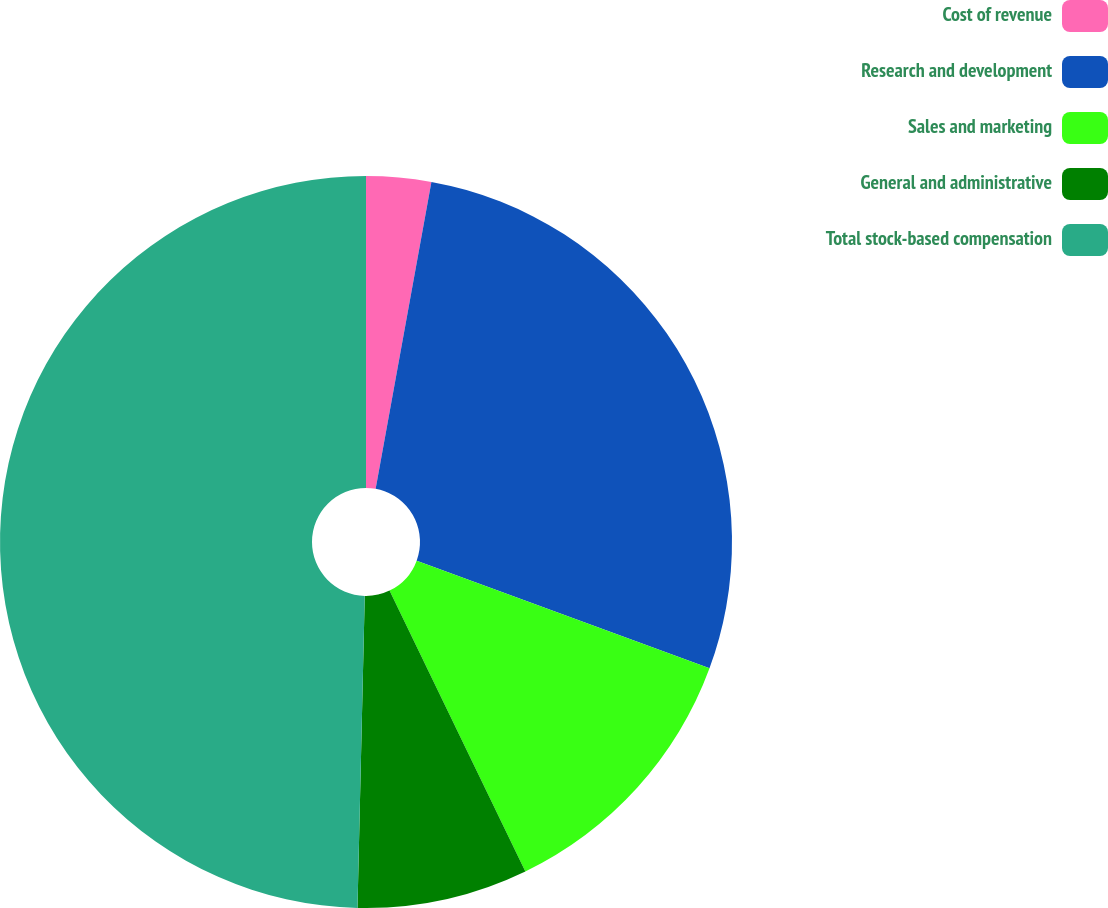<chart> <loc_0><loc_0><loc_500><loc_500><pie_chart><fcel>Cost of revenue<fcel>Research and development<fcel>Sales and marketing<fcel>General and administrative<fcel>Total stock-based compensation<nl><fcel>2.86%<fcel>27.75%<fcel>12.22%<fcel>7.54%<fcel>49.63%<nl></chart> 